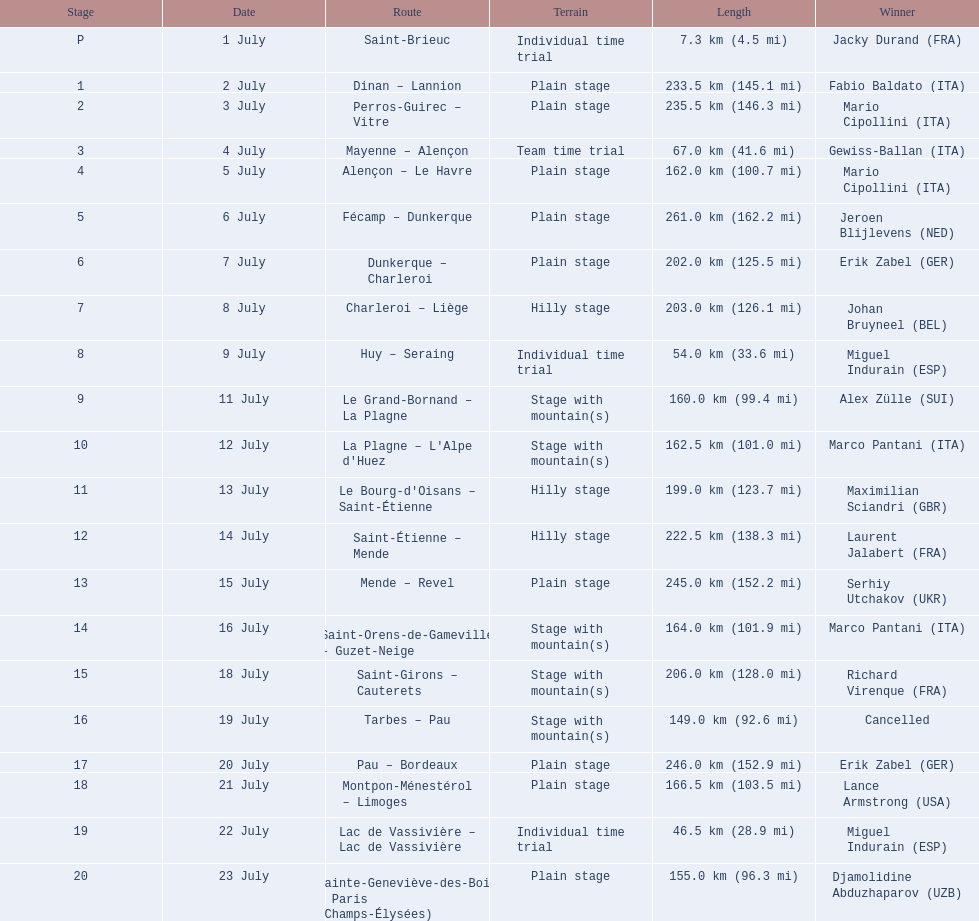What are the dates? 1 July, 2 July, 3 July, 4 July, 5 July, 6 July, 7 July, 8 July, 9 July, 11 July, 12 July, 13 July, 14 July, 15 July, 16 July, 18 July, 19 July, 20 July, 21 July, 22 July, 23 July. What is the length on 8 july? 203.0 km (126.1 mi). 